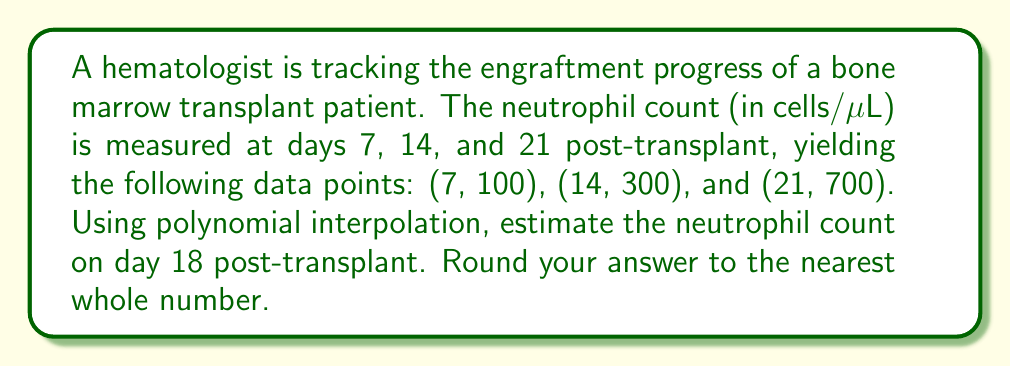Show me your answer to this math problem. 1) We need to find a quadratic polynomial of the form $f(x) = ax^2 + bx + c$ that passes through the given points.

2) Substitute the given points into the general form:
   $100 = 49a + 7b + c$
   $300 = 196a + 14b + c$
   $700 = 441a + 21b + c$

3) Subtract the first equation from the second and third:
   $200 = 147a + 7b$
   $600 = 392a + 14b$

4) Divide the second equation by 2:
   $300 = 196a + 7b$

5) Subtract this from the first equation:
   $-100 = -49a$
   $a = \frac{100}{49} \approx 2.0408$

6) Substitute this back into $200 = 147a + 7b$:
   $200 = 147(2.0408) + 7b$
   $200 = 300 + 7b$
   $-100 = 7b$
   $b = -\frac{100}{7} \approx -14.2857$

7) Substitute $a$ and $b$ into $100 = 49a + 7b + c$:
   $100 = 49(2.0408) + 7(-14.2857) + c$
   $100 = 100 - 100 + c$
   $c = 100$

8) Our polynomial is: $f(x) = 2.0408x^2 - 14.2857x + 100$

9) To estimate the neutrophil count on day 18, calculate $f(18)$:
   $f(18) = 2.0408(18^2) - 14.2857(18) + 100$
   $= 2.0408(324) - 14.2857(18) + 100$
   $= 661.2192 - 257.1426 + 100$
   $= 504.0766$

10) Rounding to the nearest whole number: 504
Answer: 504 cells/μL 